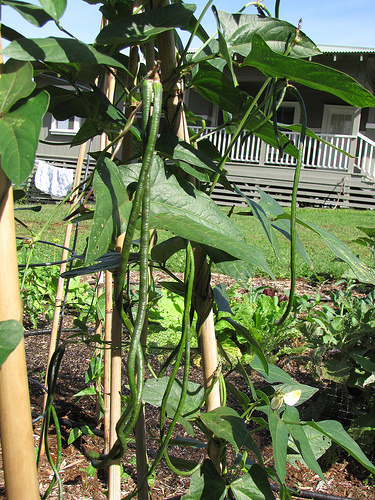<image>
Is there a vine on the house? No. The vine is not positioned on the house. They may be near each other, but the vine is not supported by or resting on top of the house. 